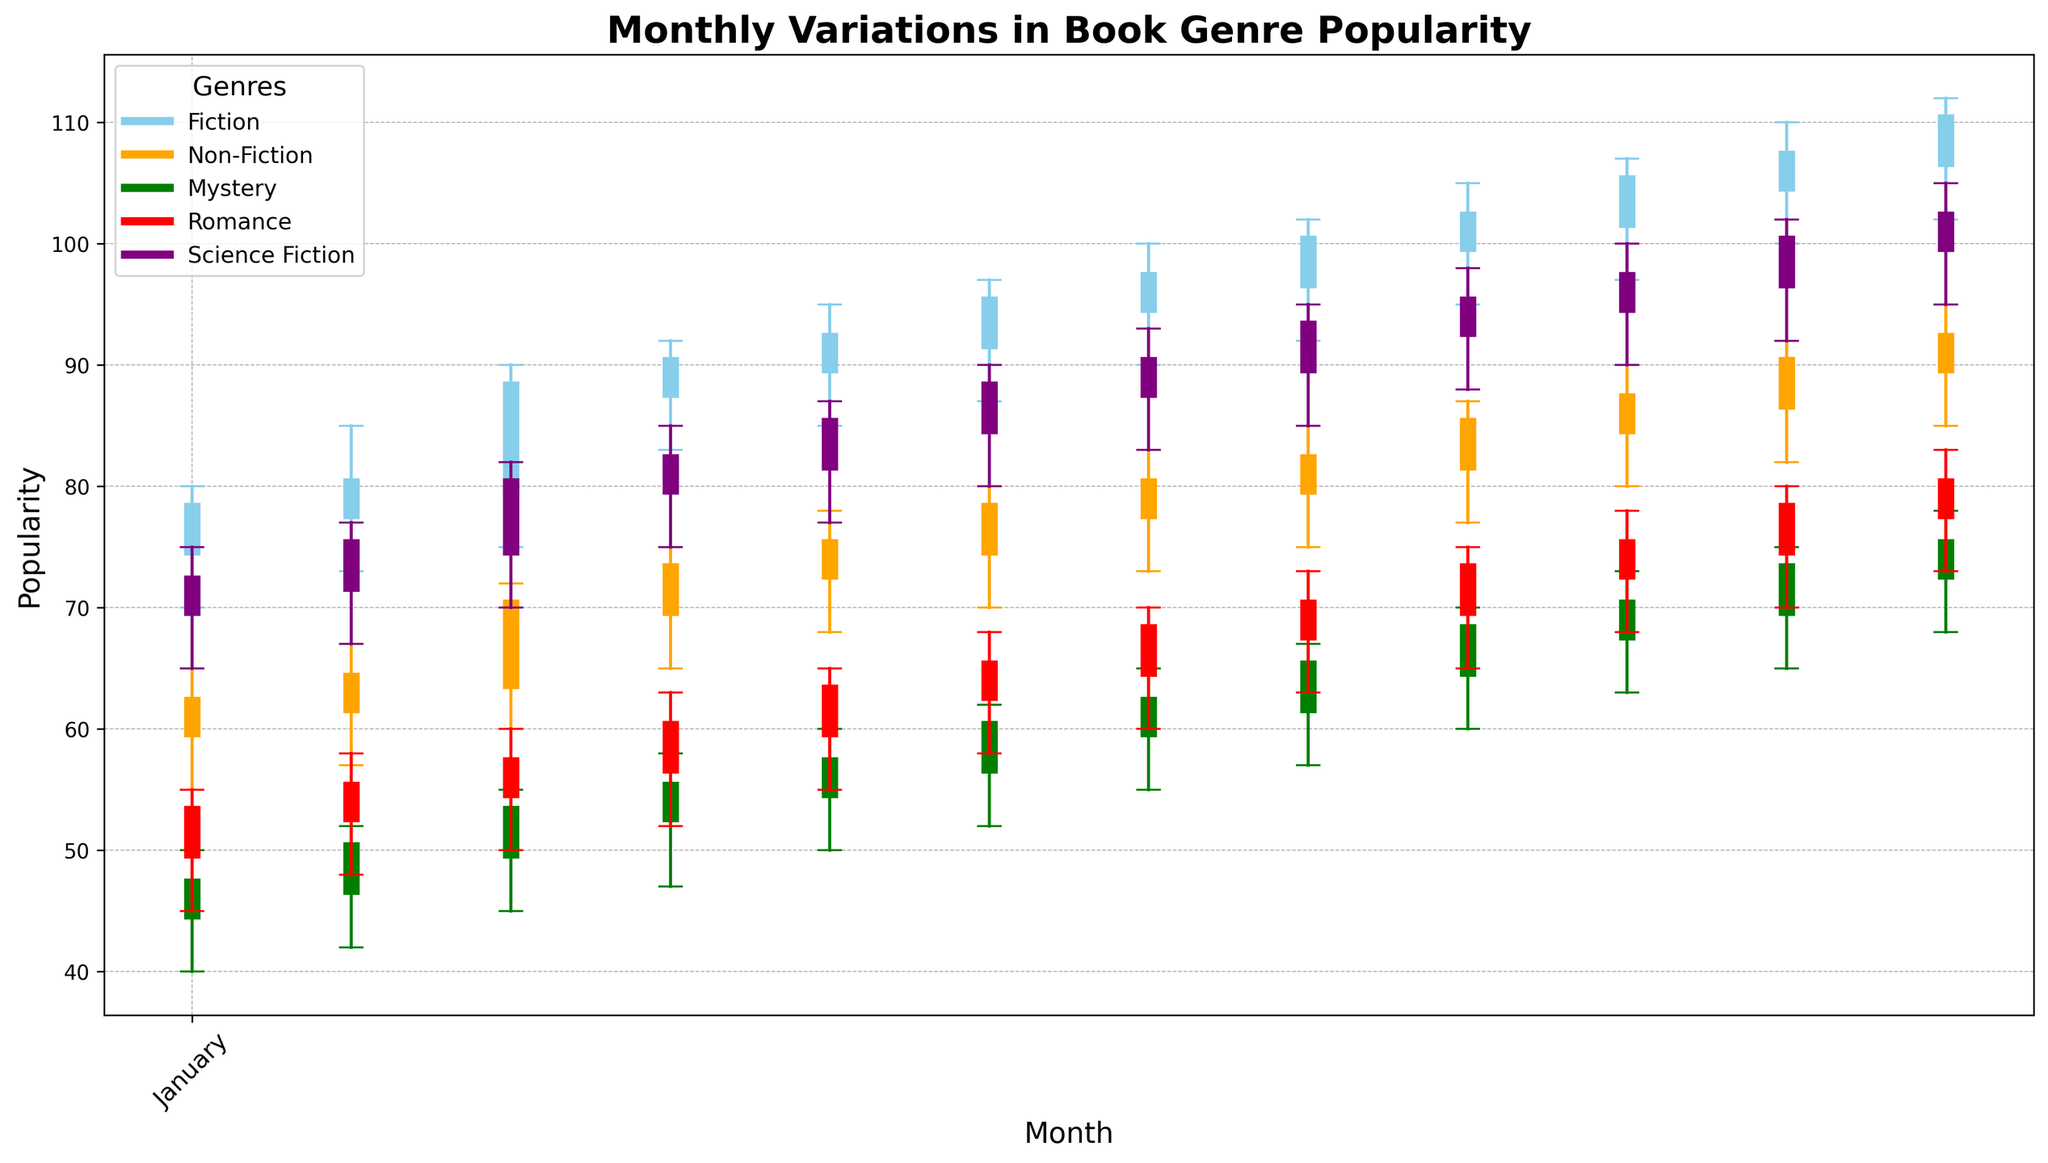What was the highest popularity value reached by the Fiction genre and in which month? To determine the highest popularity value for Fiction, look at the upper ends of the blue lines on the y-axis corresponding to each month. The highest value is 112, which occurs in December.
Answer: 112 in December How does the popularity of Romance in May compare to June? Compare the green bars for May and June. The close value (top of the thicker line) is higher in June (65) than in May (63), indicating that the popularity of Romance increased in June compared to May.
Answer: Increased in June Which genre had the most substantial increase in popularity from the opening value to the closing value in any single month? Examine the length of the thicker segments of each candlestick. The Fiction genre in March has the most substantial increase, going from an open of 80 to a close of 88, an increase of 8. No other genre and month combination shows a greater increase.
Answer: Fiction in March In which month did Non-Fiction achieve its highest closing value, and what was that value? Focus on the orange bars representing Non-Fiction. The highest closing value for Non-Fiction is 92, which is observed in December.
Answer: December with a value of 92 Compare the opening value of Science Fiction in August with its closing value in December. Which is higher? Look at the purple bars for August and December. The opening value for Science Fiction in August is 90, and the closing value in December is 102. The closing value in December is higher.
Answer: December's closing value is higher Which genre demonstrated a consistent increase in popularity from January to December? Track the general upward trend for any genre from January to December. The Fiction genre, represented by blue, shows a consistently increasing trend in its closing values each month.
Answer: Fiction What is the average closing value for Mystery in the first quarter (January to March)? Add the closing values for Mystery from January (47), February (50), and March (53), and then divide by 3. The sum is 150, and the average is 150/3 = 50.
Answer: 50 Which genre experienced the most variation between the high and low values in September? For each genre in September, subtract the low value from the high value and compare the differences. Fiction has a range of 105 - 95 = 10, Non-Fiction 87 - 77 = 10, Mystery 70 - 60 = 10, Romance 75 - 65 = 10, and Science Fiction 98 - 88 = 10. They all equally experienced the most variation (10).
Answer: All genres equally How did the opening value for Romance in December compare to its closing value in November? The opening value for Romance in December is 78, observed at the bottom of the thick red line for December. The closing value for November is 78, at the top of the thick red line for November. The values are equal.
Answer: They are equal What was the closing value trend for Non-Fiction from October to December? Look at the closing values for Non-Fiction (orange) for October, November, and December. The pattern shows an increasing trend: 87 in October, 90 in November, and 92 in December.
Answer: Increasing trend 